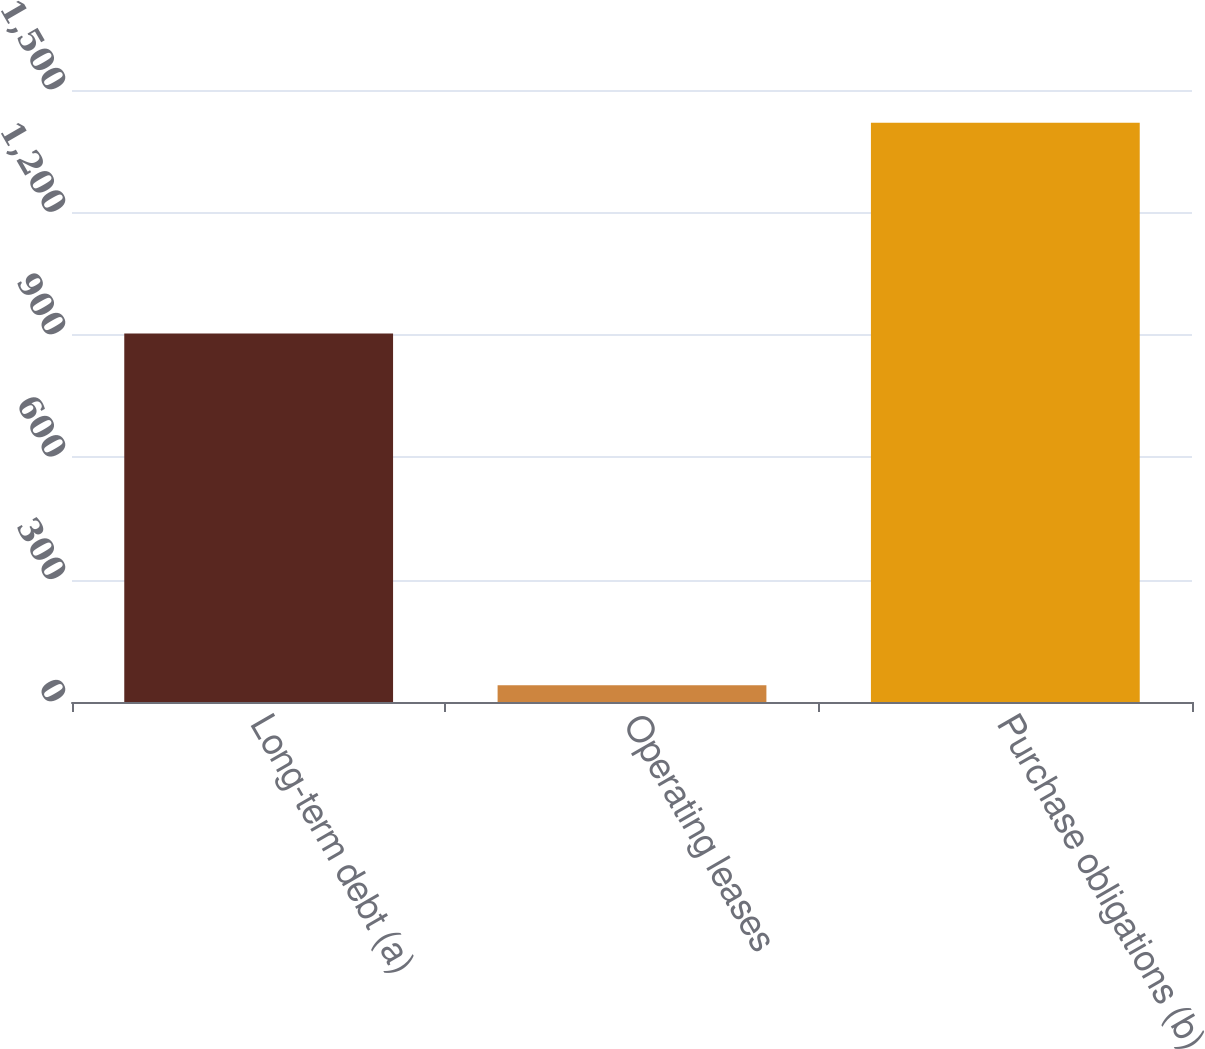Convert chart to OTSL. <chart><loc_0><loc_0><loc_500><loc_500><bar_chart><fcel>Long-term debt (a)<fcel>Operating leases<fcel>Purchase obligations (b)<nl><fcel>903<fcel>41<fcel>1420<nl></chart> 